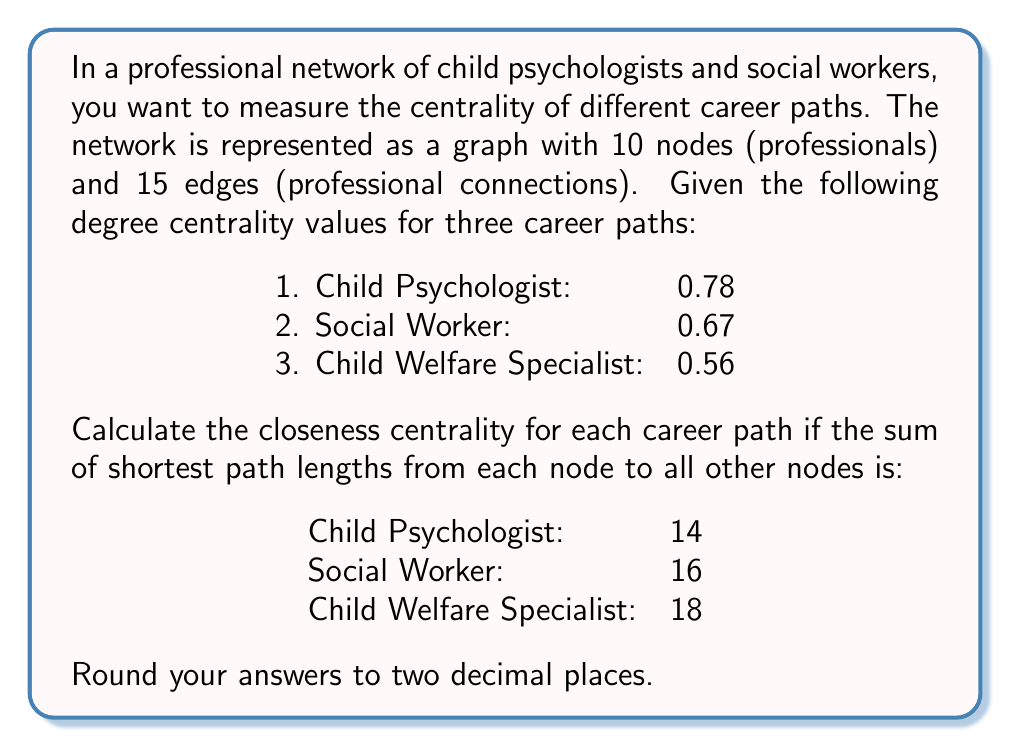What is the answer to this math problem? To solve this problem, we need to understand and apply the concept of closeness centrality in network analysis. Closeness centrality measures how close a node is to all other nodes in the network. It is calculated as the reciprocal of the sum of the shortest path lengths from a node to all other nodes in the network.

The formula for closeness centrality is:

$$ C_C(v) = \frac{n-1}{\sum_{u \neq v} d(u,v)} $$

Where:
- $C_C(v)$ is the closeness centrality of node $v$
- $n$ is the total number of nodes in the network
- $d(u,v)$ is the shortest path length between nodes $u$ and $v$

Given:
- Total nodes in the network: $n = 10$
- Sum of shortest path lengths for each career path:
  1. Child Psychologist: 14
  2. Social Worker: 16
  3. Child Welfare Specialist: 18

Let's calculate the closeness centrality for each career path:

1. Child Psychologist:
$$ C_C(\text{Child Psychologist}) = \frac{10-1}{14} = \frac{9}{14} \approx 0.6429 $$

2. Social Worker:
$$ C_C(\text{Social Worker}) = \frac{10-1}{16} = \frac{9}{16} = 0.5625 $$

3. Child Welfare Specialist:
$$ C_C(\text{Child Welfare Specialist}) = \frac{10-1}{18} = \frac{9}{18} = 0.5000 $$

Rounding to two decimal places, we get:
1. Child Psychologist: 0.64
2. Social Worker: 0.56
3. Child Welfare Specialist: 0.50
Answer: The closeness centrality values for the three career paths are:
1. Child Psychologist: 0.64
2. Social Worker: 0.56
3. Child Welfare Specialist: 0.50 